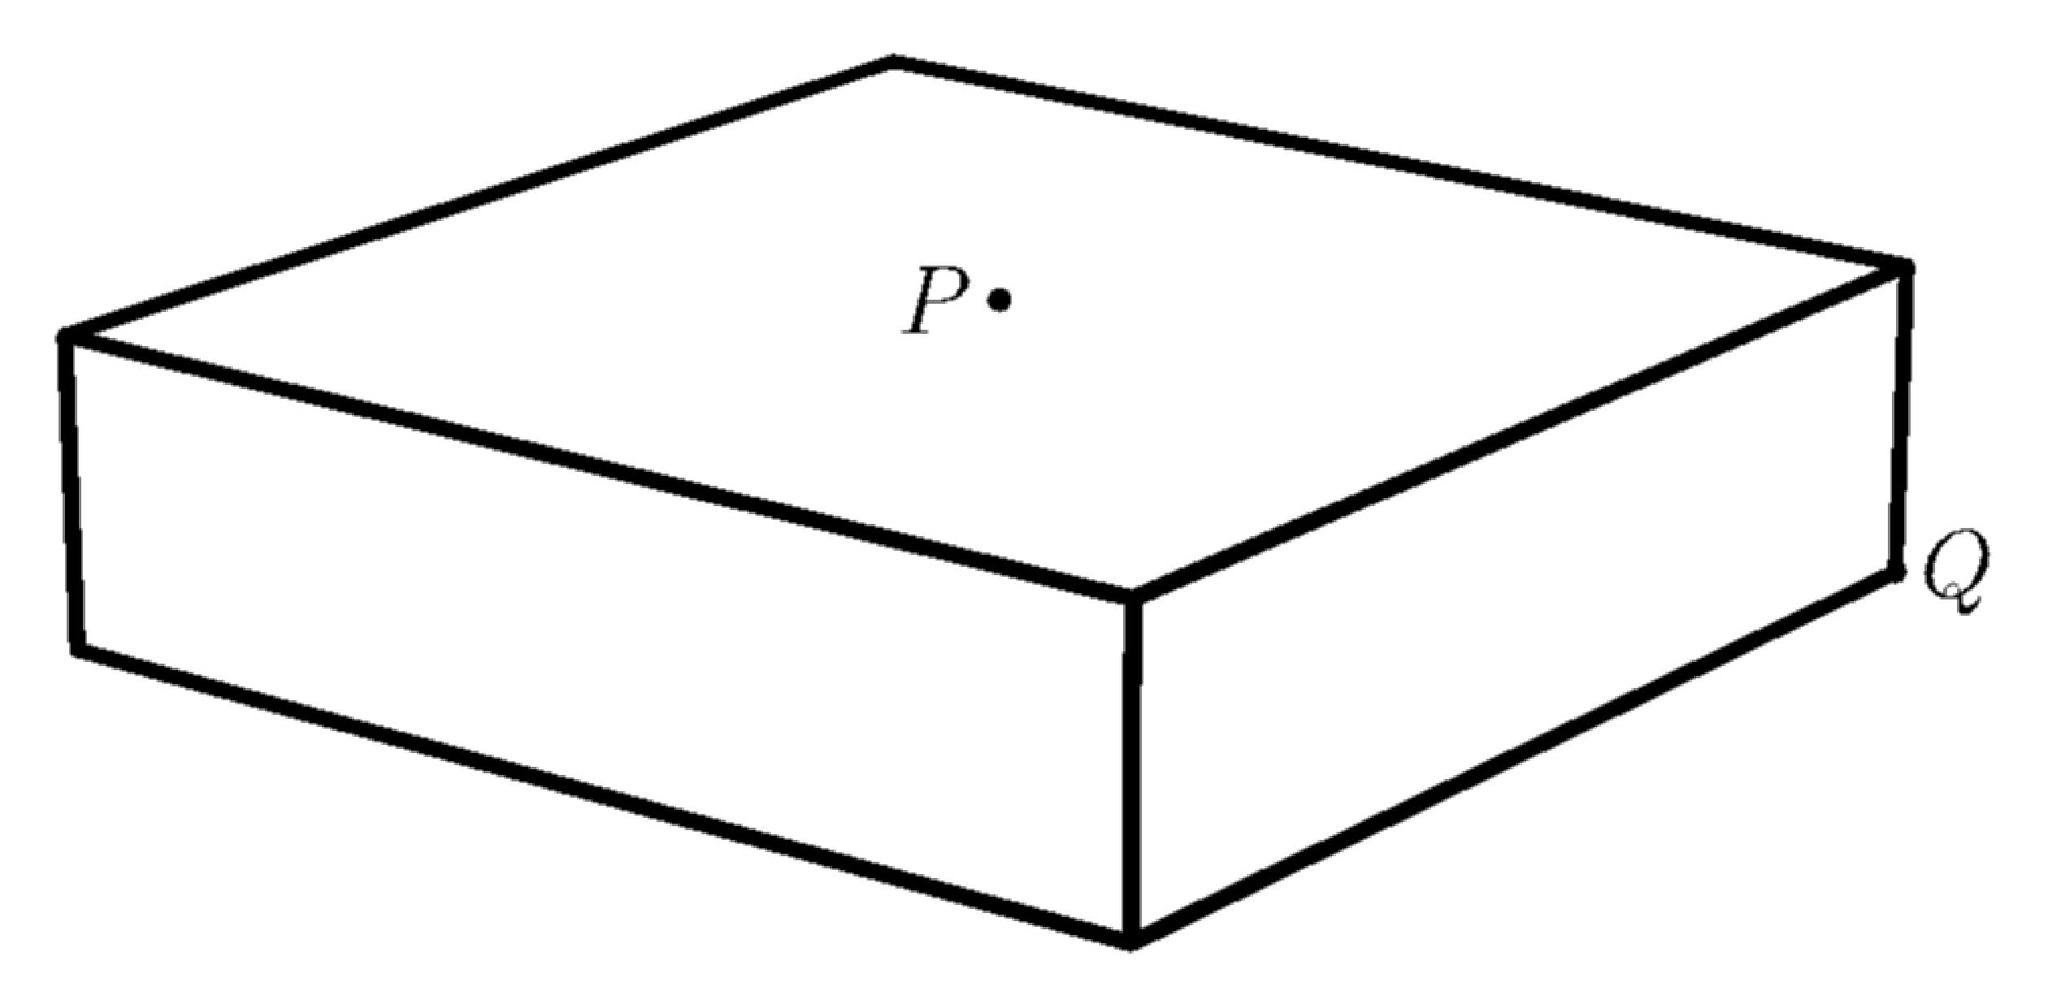A rectangular box is 4 cm thick, and its square bases measure 16 cm by 16 cm. What is the distance, in centimeters, from the center point $P$ of one square base to corner $Q$ of the opposite base? Express your answer in simplest terms. To find the distance between the center point $P$ of one square base and the corner $Q$ of the opposite base of the rectangular box, we apply the three-dimensional Pythagorean theorem. The box is 4 cm thick, and each side of the square bases measures 16 cm. First, calculate the diagonal of the base, which is sqrt(16^2 + 16^2) = sqrt(512) = 16sqrt(2) cm. Then, apply the theorem again to include the thickness of the box: sqrt((16sqrt(2))^2 + 4^2) = sqrt(512 + 16) = sqrt(528) = 4sqrt(33) cm. Thus, the required distance is 4sqrt(33) cm. 